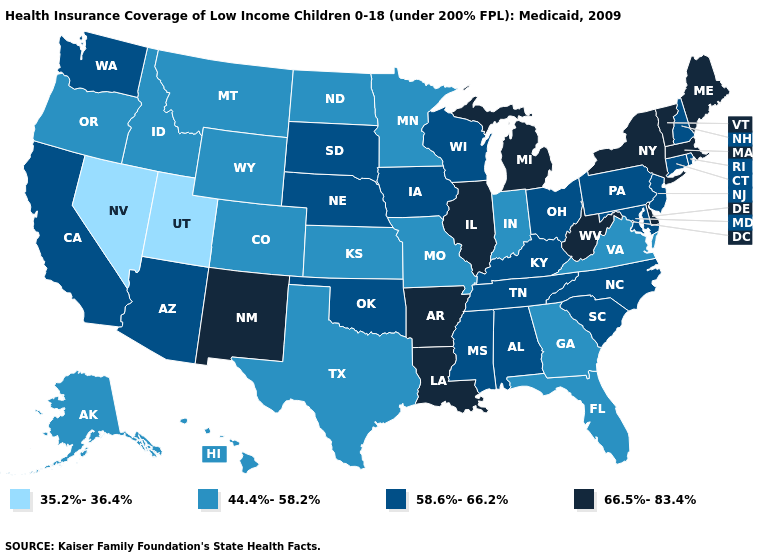What is the highest value in the USA?
Give a very brief answer. 66.5%-83.4%. Among the states that border Nevada , which have the lowest value?
Quick response, please. Utah. Name the states that have a value in the range 66.5%-83.4%?
Be succinct. Arkansas, Delaware, Illinois, Louisiana, Maine, Massachusetts, Michigan, New Mexico, New York, Vermont, West Virginia. What is the highest value in the South ?
Give a very brief answer. 66.5%-83.4%. Name the states that have a value in the range 35.2%-36.4%?
Short answer required. Nevada, Utah. What is the lowest value in states that border Arkansas?
Short answer required. 44.4%-58.2%. Name the states that have a value in the range 35.2%-36.4%?
Quick response, please. Nevada, Utah. Name the states that have a value in the range 66.5%-83.4%?
Give a very brief answer. Arkansas, Delaware, Illinois, Louisiana, Maine, Massachusetts, Michigan, New Mexico, New York, Vermont, West Virginia. What is the lowest value in the Northeast?
Give a very brief answer. 58.6%-66.2%. What is the highest value in the USA?
Concise answer only. 66.5%-83.4%. What is the value of Utah?
Concise answer only. 35.2%-36.4%. What is the value of Connecticut?
Concise answer only. 58.6%-66.2%. Which states have the highest value in the USA?
Answer briefly. Arkansas, Delaware, Illinois, Louisiana, Maine, Massachusetts, Michigan, New Mexico, New York, Vermont, West Virginia. What is the lowest value in states that border Connecticut?
Be succinct. 58.6%-66.2%. Does the map have missing data?
Be succinct. No. 